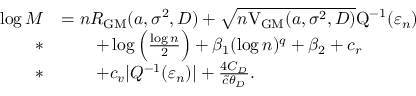<formula> <loc_0><loc_0><loc_500><loc_500>\begin{array} { r l } { \log M } & { = n R _ { G M } ( a , \sigma ^ { 2 } , D ) + \sqrt { n V _ { G M } ( a , \sigma ^ { 2 } , D ) } Q ^ { - 1 } ( \varepsilon _ { n } ) } \\ { * } & { \quad + \log \left ( \frac { \log n } { 2 } \right ) + \beta _ { 1 } ( \log n ) ^ { q } + \beta _ { 2 } + c _ { r } } \\ { * } & { \quad + c _ { v } | Q ^ { - 1 } ( \varepsilon _ { n } ) | + \frac { 4 C _ { D } } { \tilde { c } \theta _ { D } } . } \end{array}</formula> 